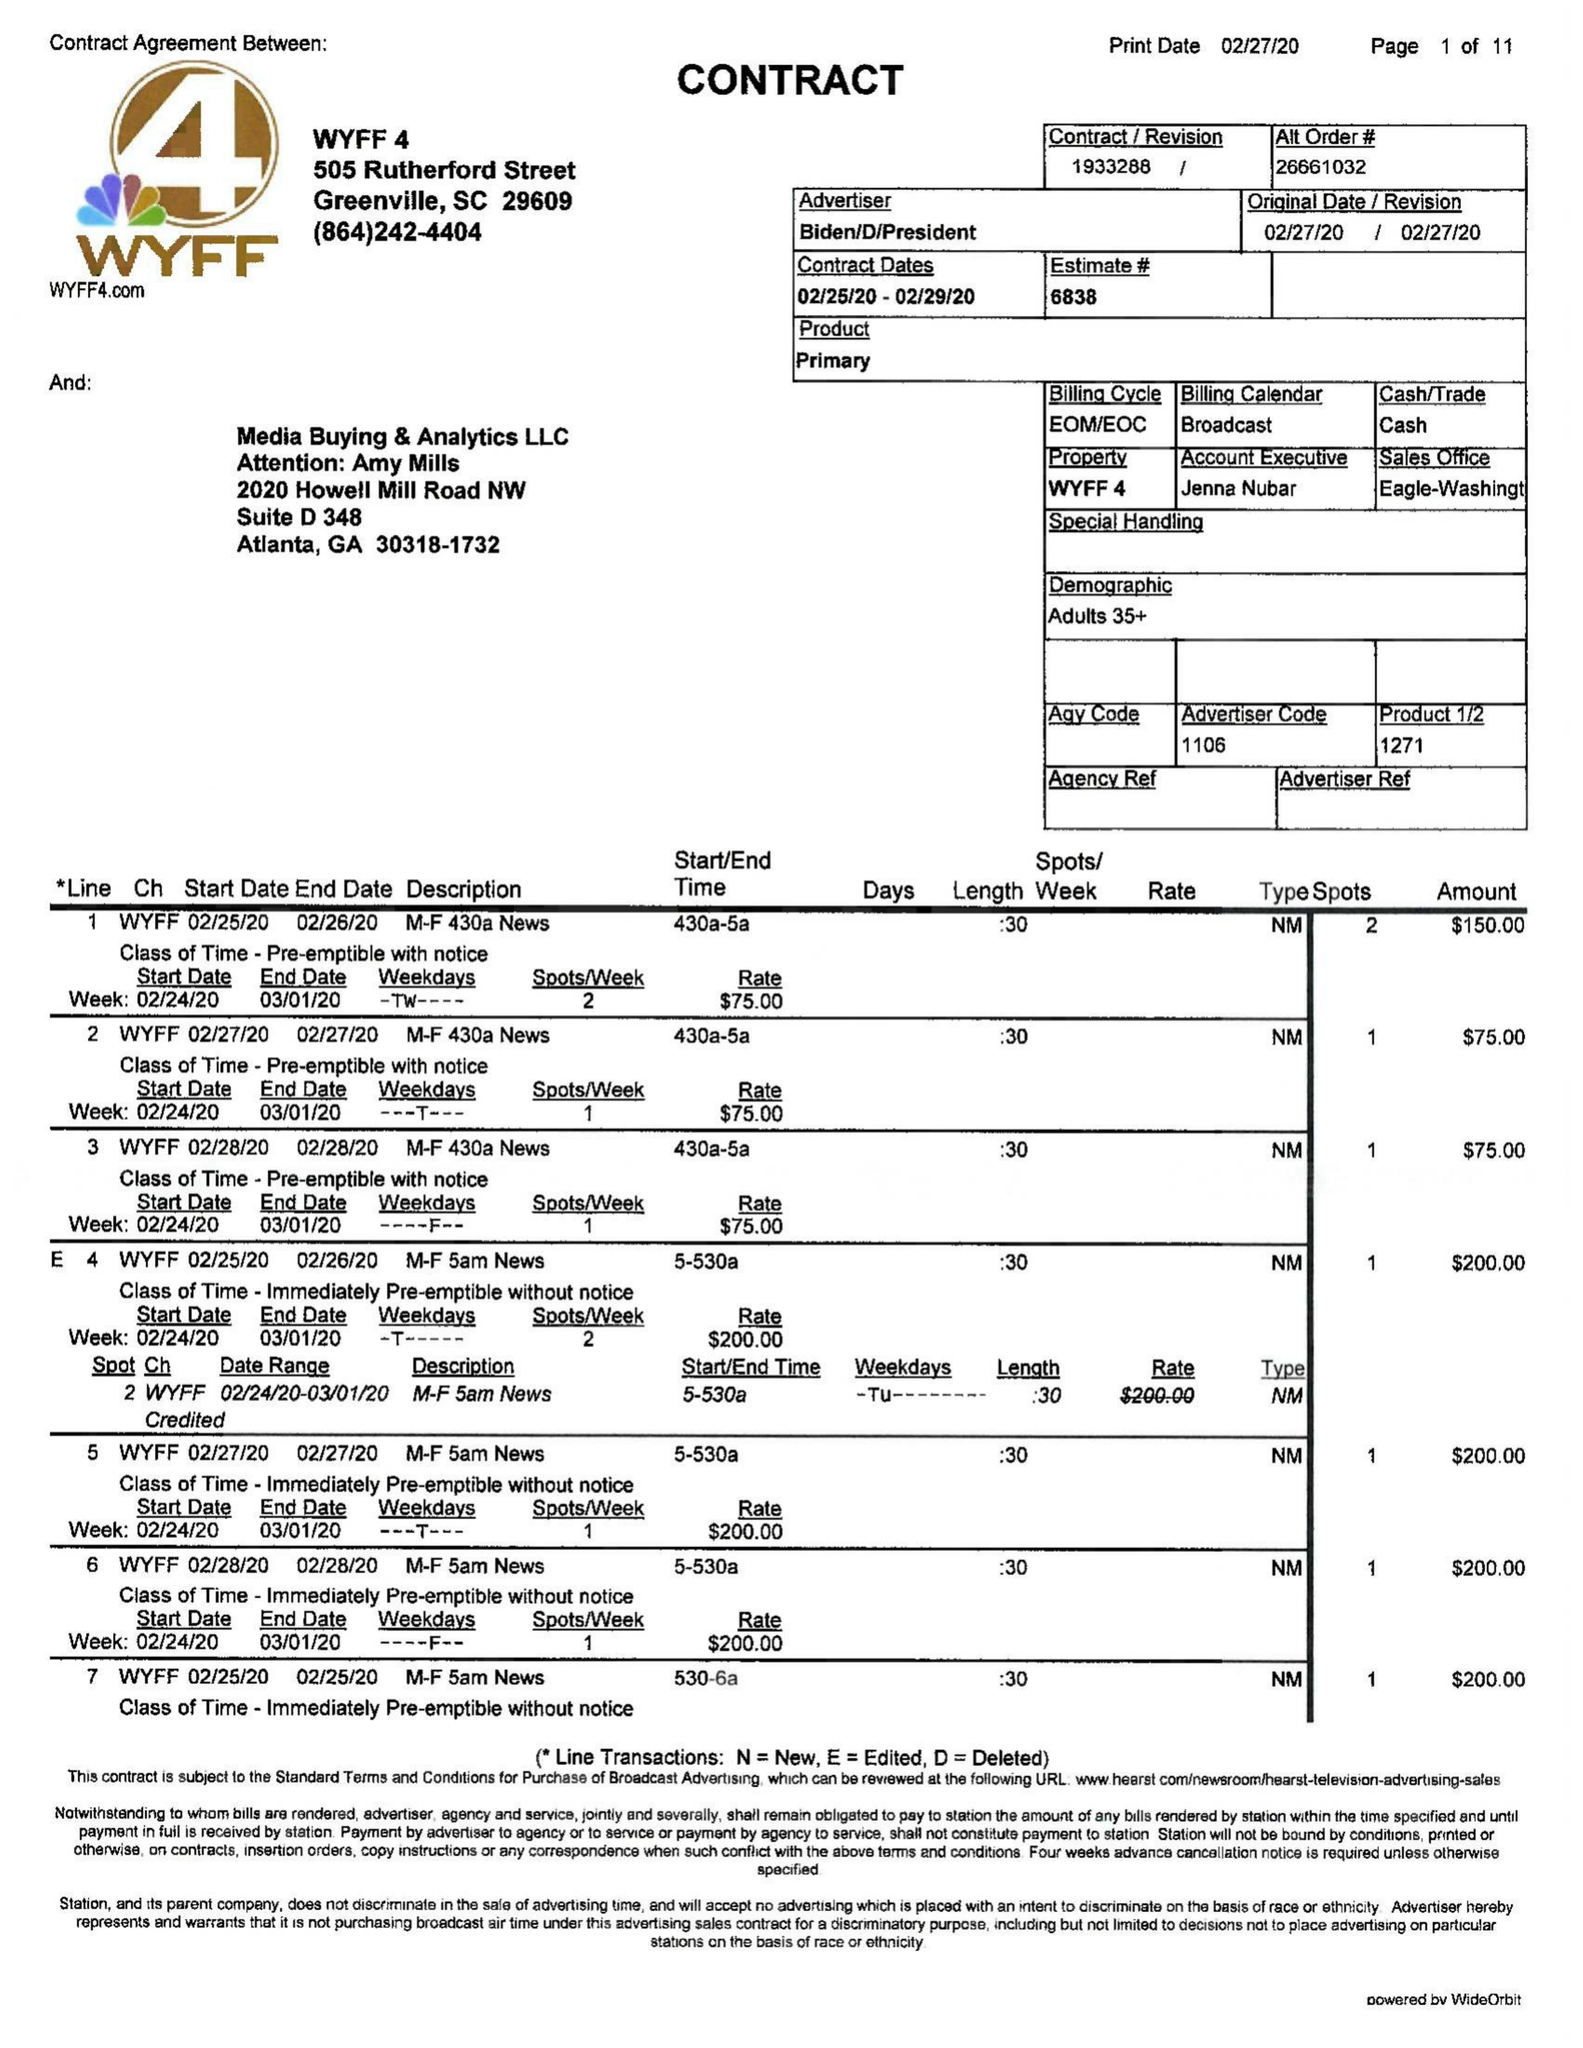What is the value for the gross_amount?
Answer the question using a single word or phrase. 44585.00 